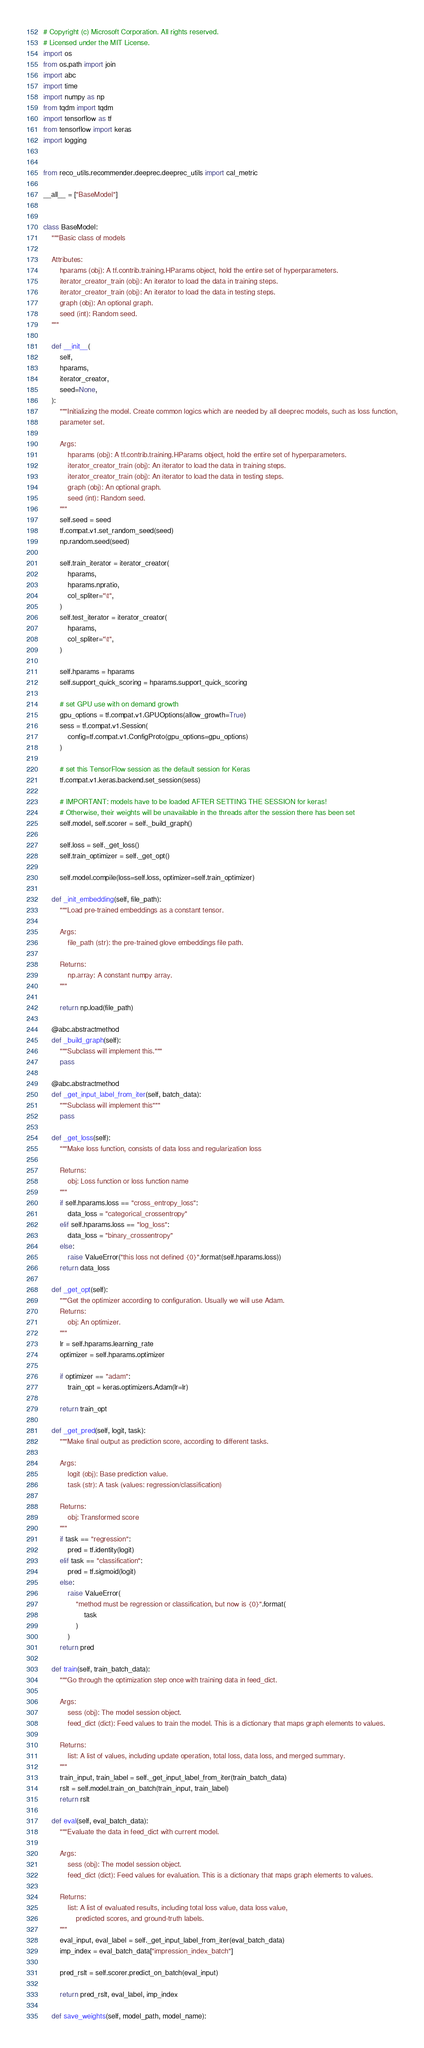<code> <loc_0><loc_0><loc_500><loc_500><_Python_># Copyright (c) Microsoft Corporation. All rights reserved.
# Licensed under the MIT License.
import os
from os.path import join
import abc
import time
import numpy as np
from tqdm import tqdm
import tensorflow as tf
from tensorflow import keras
import logging


from reco_utils.recommender.deeprec.deeprec_utils import cal_metric

__all__ = ["BaseModel"]


class BaseModel:
    """Basic class of models

    Attributes:
        hparams (obj): A tf.contrib.training.HParams object, hold the entire set of hyperparameters.
        iterator_creator_train (obj): An iterator to load the data in training steps.
        iterator_creator_train (obj): An iterator to load the data in testing steps.
        graph (obj): An optional graph.
        seed (int): Random seed.
    """

    def __init__(
        self,
        hparams,
        iterator_creator,
        seed=None,
    ):
        """Initializing the model. Create common logics which are needed by all deeprec models, such as loss function,
        parameter set.

        Args:
            hparams (obj): A tf.contrib.training.HParams object, hold the entire set of hyperparameters.
            iterator_creator_train (obj): An iterator to load the data in training steps.
            iterator_creator_train (obj): An iterator to load the data in testing steps.
            graph (obj): An optional graph.
            seed (int): Random seed.
        """
        self.seed = seed
        tf.compat.v1.set_random_seed(seed)
        np.random.seed(seed)

        self.train_iterator = iterator_creator(
            hparams,
            hparams.npratio,
            col_spliter="\t",
        )
        self.test_iterator = iterator_creator(
            hparams,
            col_spliter="\t",
        )

        self.hparams = hparams
        self.support_quick_scoring = hparams.support_quick_scoring

        # set GPU use with on demand growth
        gpu_options = tf.compat.v1.GPUOptions(allow_growth=True)
        sess = tf.compat.v1.Session(
            config=tf.compat.v1.ConfigProto(gpu_options=gpu_options)
        )

        # set this TensorFlow session as the default session for Keras
        tf.compat.v1.keras.backend.set_session(sess)

        # IMPORTANT: models have to be loaded AFTER SETTING THE SESSION for keras!
        # Otherwise, their weights will be unavailable in the threads after the session there has been set
        self.model, self.scorer = self._build_graph()

        self.loss = self._get_loss()
        self.train_optimizer = self._get_opt()

        self.model.compile(loss=self.loss, optimizer=self.train_optimizer)

    def _init_embedding(self, file_path):
        """Load pre-trained embeddings as a constant tensor.

        Args:
            file_path (str): the pre-trained glove embeddings file path.

        Returns:
            np.array: A constant numpy array.
        """

        return np.load(file_path)

    @abc.abstractmethod
    def _build_graph(self):
        """Subclass will implement this."""
        pass

    @abc.abstractmethod
    def _get_input_label_from_iter(self, batch_data):
        """Subclass will implement this"""
        pass

    def _get_loss(self):
        """Make loss function, consists of data loss and regularization loss

        Returns:
            obj: Loss function or loss function name
        """
        if self.hparams.loss == "cross_entropy_loss":
            data_loss = "categorical_crossentropy"
        elif self.hparams.loss == "log_loss":
            data_loss = "binary_crossentropy"
        else:
            raise ValueError("this loss not defined {0}".format(self.hparams.loss))
        return data_loss

    def _get_opt(self):
        """Get the optimizer according to configuration. Usually we will use Adam.
        Returns:
            obj: An optimizer.
        """
        lr = self.hparams.learning_rate
        optimizer = self.hparams.optimizer

        if optimizer == "adam":
            train_opt = keras.optimizers.Adam(lr=lr)

        return train_opt

    def _get_pred(self, logit, task):
        """Make final output as prediction score, according to different tasks.

        Args:
            logit (obj): Base prediction value.
            task (str): A task (values: regression/classification)

        Returns:
            obj: Transformed score
        """
        if task == "regression":
            pred = tf.identity(logit)
        elif task == "classification":
            pred = tf.sigmoid(logit)
        else:
            raise ValueError(
                "method must be regression or classification, but now is {0}".format(
                    task
                )
            )
        return pred

    def train(self, train_batch_data):
        """Go through the optimization step once with training data in feed_dict.

        Args:
            sess (obj): The model session object.
            feed_dict (dict): Feed values to train the model. This is a dictionary that maps graph elements to values.

        Returns:
            list: A list of values, including update operation, total loss, data loss, and merged summary.
        """
        train_input, train_label = self._get_input_label_from_iter(train_batch_data)
        rslt = self.model.train_on_batch(train_input, train_label)
        return rslt

    def eval(self, eval_batch_data):
        """Evaluate the data in feed_dict with current model.

        Args:
            sess (obj): The model session object.
            feed_dict (dict): Feed values for evaluation. This is a dictionary that maps graph elements to values.

        Returns:
            list: A list of evaluated results, including total loss value, data loss value,
                predicted scores, and ground-truth labels.
        """
        eval_input, eval_label = self._get_input_label_from_iter(eval_batch_data)
        imp_index = eval_batch_data["impression_index_batch"]

        pred_rslt = self.scorer.predict_on_batch(eval_input)

        return pred_rslt, eval_label, imp_index

    def save_weights(self, model_path, model_name):</code> 